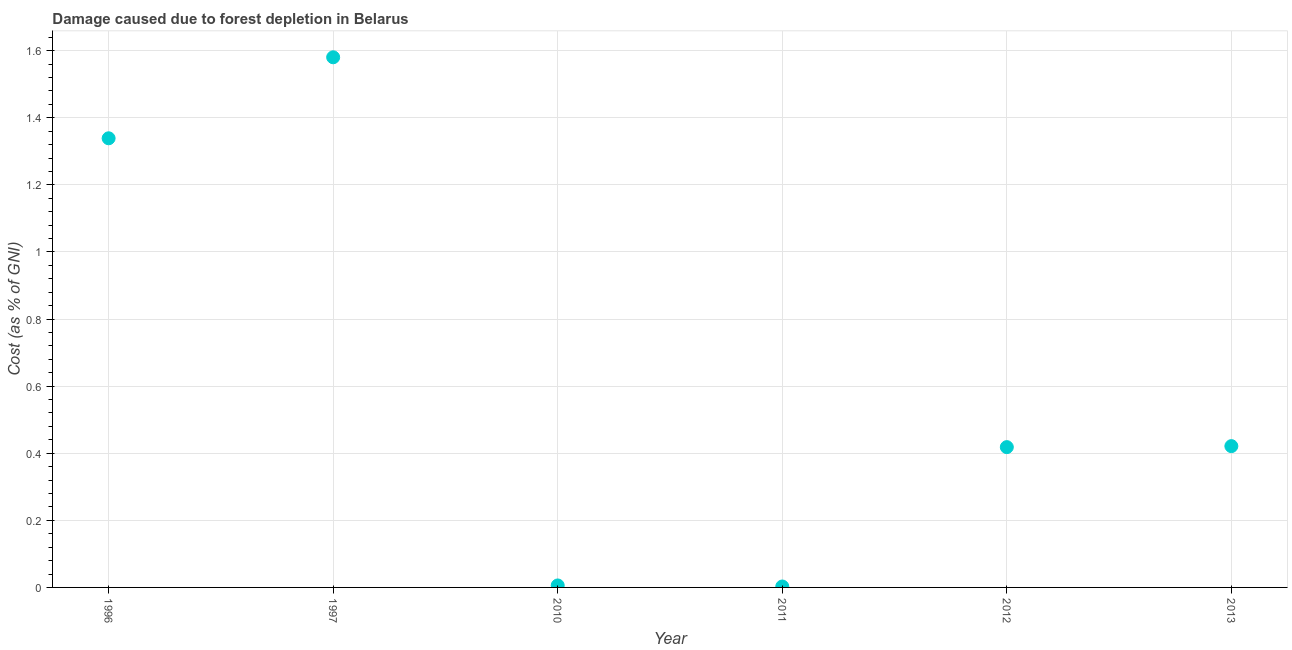What is the damage caused due to forest depletion in 2011?
Ensure brevity in your answer.  0. Across all years, what is the maximum damage caused due to forest depletion?
Keep it short and to the point. 1.58. Across all years, what is the minimum damage caused due to forest depletion?
Offer a terse response. 0. In which year was the damage caused due to forest depletion maximum?
Provide a succinct answer. 1997. In which year was the damage caused due to forest depletion minimum?
Your answer should be compact. 2011. What is the sum of the damage caused due to forest depletion?
Give a very brief answer. 3.77. What is the difference between the damage caused due to forest depletion in 1997 and 2011?
Offer a very short reply. 1.58. What is the average damage caused due to forest depletion per year?
Offer a very short reply. 0.63. What is the median damage caused due to forest depletion?
Your response must be concise. 0.42. What is the ratio of the damage caused due to forest depletion in 1997 to that in 2010?
Your response must be concise. 268.48. What is the difference between the highest and the second highest damage caused due to forest depletion?
Your answer should be compact. 0.24. What is the difference between the highest and the lowest damage caused due to forest depletion?
Provide a succinct answer. 1.58. In how many years, is the damage caused due to forest depletion greater than the average damage caused due to forest depletion taken over all years?
Your answer should be compact. 2. How many dotlines are there?
Your answer should be very brief. 1. How many years are there in the graph?
Give a very brief answer. 6. Are the values on the major ticks of Y-axis written in scientific E-notation?
Ensure brevity in your answer.  No. What is the title of the graph?
Give a very brief answer. Damage caused due to forest depletion in Belarus. What is the label or title of the Y-axis?
Give a very brief answer. Cost (as % of GNI). What is the Cost (as % of GNI) in 1996?
Your response must be concise. 1.34. What is the Cost (as % of GNI) in 1997?
Give a very brief answer. 1.58. What is the Cost (as % of GNI) in 2010?
Ensure brevity in your answer.  0.01. What is the Cost (as % of GNI) in 2011?
Provide a succinct answer. 0. What is the Cost (as % of GNI) in 2012?
Provide a succinct answer. 0.42. What is the Cost (as % of GNI) in 2013?
Ensure brevity in your answer.  0.42. What is the difference between the Cost (as % of GNI) in 1996 and 1997?
Provide a succinct answer. -0.24. What is the difference between the Cost (as % of GNI) in 1996 and 2010?
Offer a terse response. 1.33. What is the difference between the Cost (as % of GNI) in 1996 and 2011?
Make the answer very short. 1.34. What is the difference between the Cost (as % of GNI) in 1996 and 2012?
Make the answer very short. 0.92. What is the difference between the Cost (as % of GNI) in 1996 and 2013?
Provide a succinct answer. 0.92. What is the difference between the Cost (as % of GNI) in 1997 and 2010?
Ensure brevity in your answer.  1.57. What is the difference between the Cost (as % of GNI) in 1997 and 2011?
Offer a terse response. 1.58. What is the difference between the Cost (as % of GNI) in 1997 and 2012?
Your answer should be very brief. 1.16. What is the difference between the Cost (as % of GNI) in 1997 and 2013?
Offer a terse response. 1.16. What is the difference between the Cost (as % of GNI) in 2010 and 2011?
Keep it short and to the point. 0. What is the difference between the Cost (as % of GNI) in 2010 and 2012?
Make the answer very short. -0.41. What is the difference between the Cost (as % of GNI) in 2010 and 2013?
Make the answer very short. -0.42. What is the difference between the Cost (as % of GNI) in 2011 and 2012?
Provide a short and direct response. -0.42. What is the difference between the Cost (as % of GNI) in 2011 and 2013?
Give a very brief answer. -0.42. What is the difference between the Cost (as % of GNI) in 2012 and 2013?
Make the answer very short. -0. What is the ratio of the Cost (as % of GNI) in 1996 to that in 1997?
Offer a terse response. 0.85. What is the ratio of the Cost (as % of GNI) in 1996 to that in 2010?
Offer a very short reply. 227.46. What is the ratio of the Cost (as % of GNI) in 1996 to that in 2011?
Offer a very short reply. 484.5. What is the ratio of the Cost (as % of GNI) in 1996 to that in 2012?
Your response must be concise. 3.2. What is the ratio of the Cost (as % of GNI) in 1996 to that in 2013?
Ensure brevity in your answer.  3.18. What is the ratio of the Cost (as % of GNI) in 1997 to that in 2010?
Provide a short and direct response. 268.48. What is the ratio of the Cost (as % of GNI) in 1997 to that in 2011?
Your answer should be compact. 571.88. What is the ratio of the Cost (as % of GNI) in 1997 to that in 2012?
Your answer should be compact. 3.78. What is the ratio of the Cost (as % of GNI) in 1997 to that in 2013?
Keep it short and to the point. 3.75. What is the ratio of the Cost (as % of GNI) in 2010 to that in 2011?
Ensure brevity in your answer.  2.13. What is the ratio of the Cost (as % of GNI) in 2010 to that in 2012?
Your response must be concise. 0.01. What is the ratio of the Cost (as % of GNI) in 2010 to that in 2013?
Offer a very short reply. 0.01. What is the ratio of the Cost (as % of GNI) in 2011 to that in 2012?
Provide a succinct answer. 0.01. What is the ratio of the Cost (as % of GNI) in 2011 to that in 2013?
Your answer should be very brief. 0.01. 